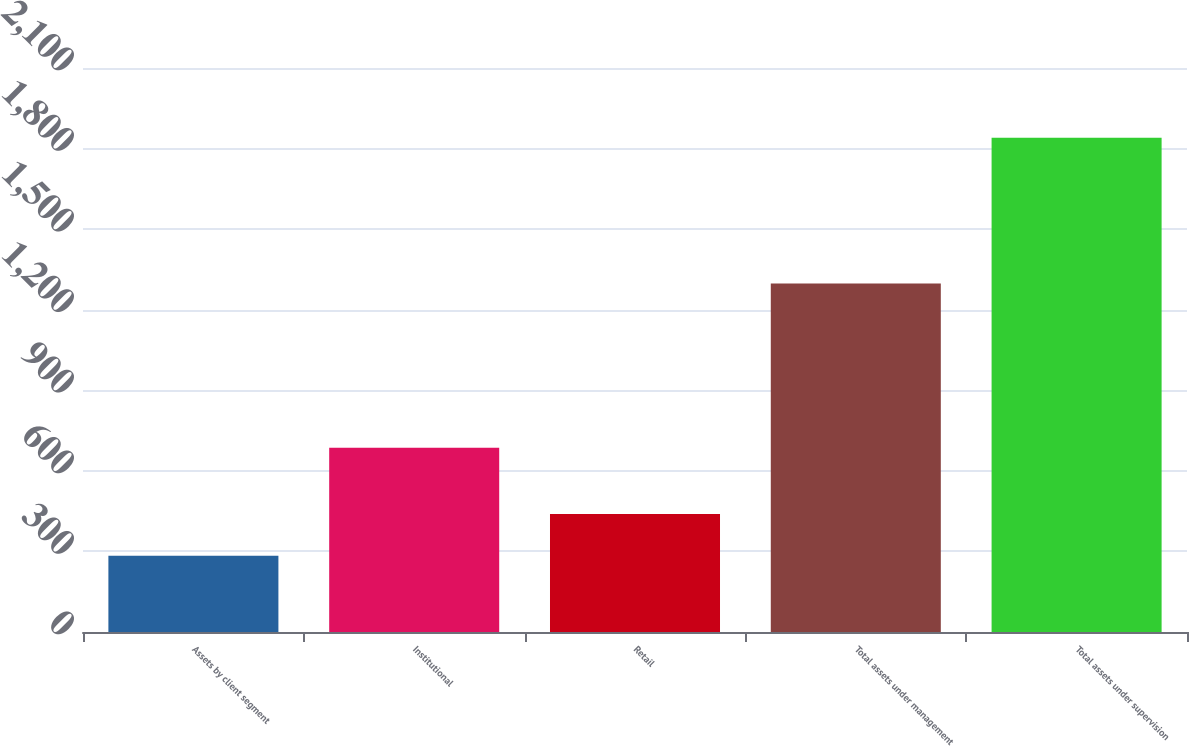Convert chart. <chart><loc_0><loc_0><loc_500><loc_500><bar_chart><fcel>Assets by client segment<fcel>Institutional<fcel>Retail<fcel>Total assets under management<fcel>Total assets under supervision<nl><fcel>284<fcel>686<fcel>439.6<fcel>1298<fcel>1840<nl></chart> 